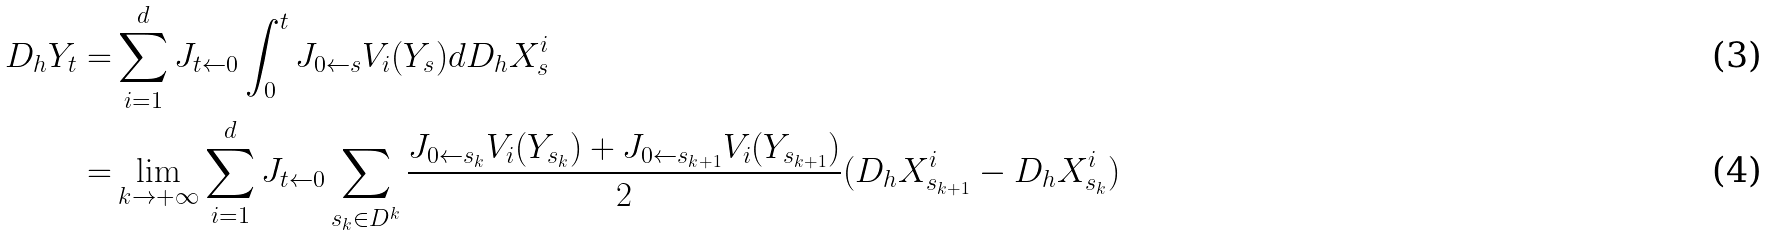Convert formula to latex. <formula><loc_0><loc_0><loc_500><loc_500>D _ { h } Y _ { t } = & \sum _ { i = 1 } ^ { d } J _ { t \leftarrow 0 } \int _ { 0 } ^ { t } J _ { 0 \leftarrow s } V _ { i } ( Y _ { s } ) d D _ { h } X ^ { i } _ { s } \\ = & \lim _ { k \rightarrow + \infty } \sum _ { i = 1 } ^ { d } J _ { t \leftarrow 0 } \sum _ { s _ { k } \in D ^ { k } } \frac { J _ { 0 \leftarrow { s _ { k } } } V _ { i } ( Y _ { s _ { k } } ) + J _ { 0 \leftarrow { s _ { k + 1 } } } V _ { i } ( Y _ { s _ { k + 1 } } ) } { 2 } ( D _ { h } X ^ { i } _ { s _ { k + 1 } } - D _ { h } X ^ { i } _ { s _ { k } } )</formula> 